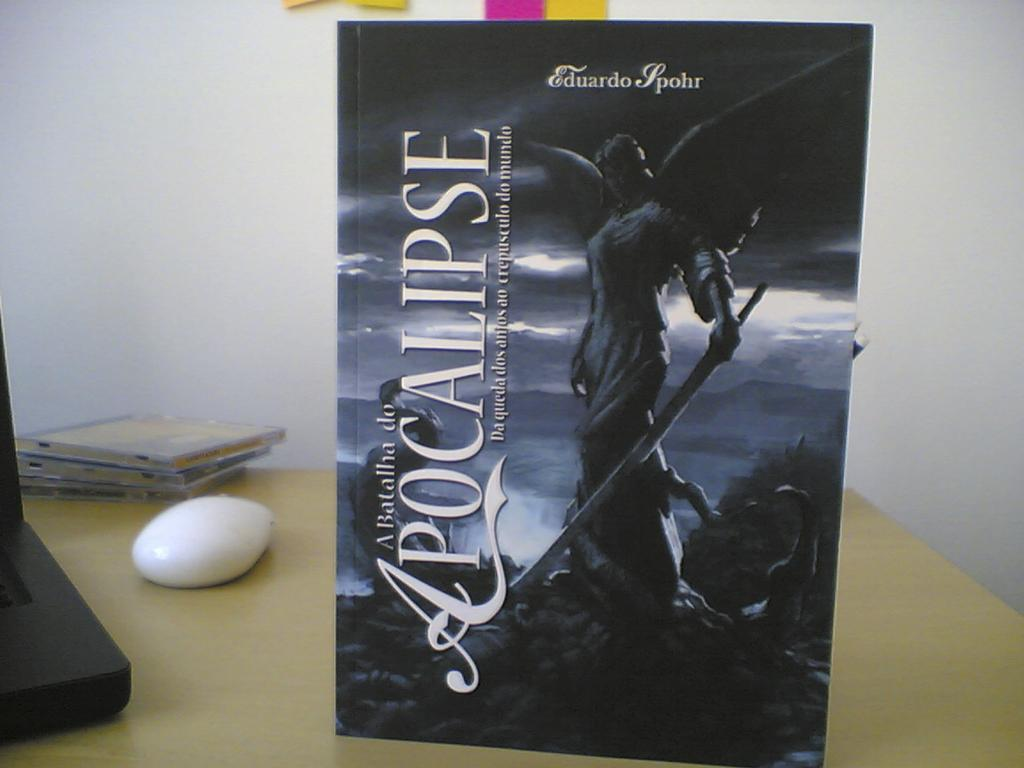Provide a one-sentence caption for the provided image. A picture of a winged angel is on a desk and it is titled A Batallina de Apocalipse. 